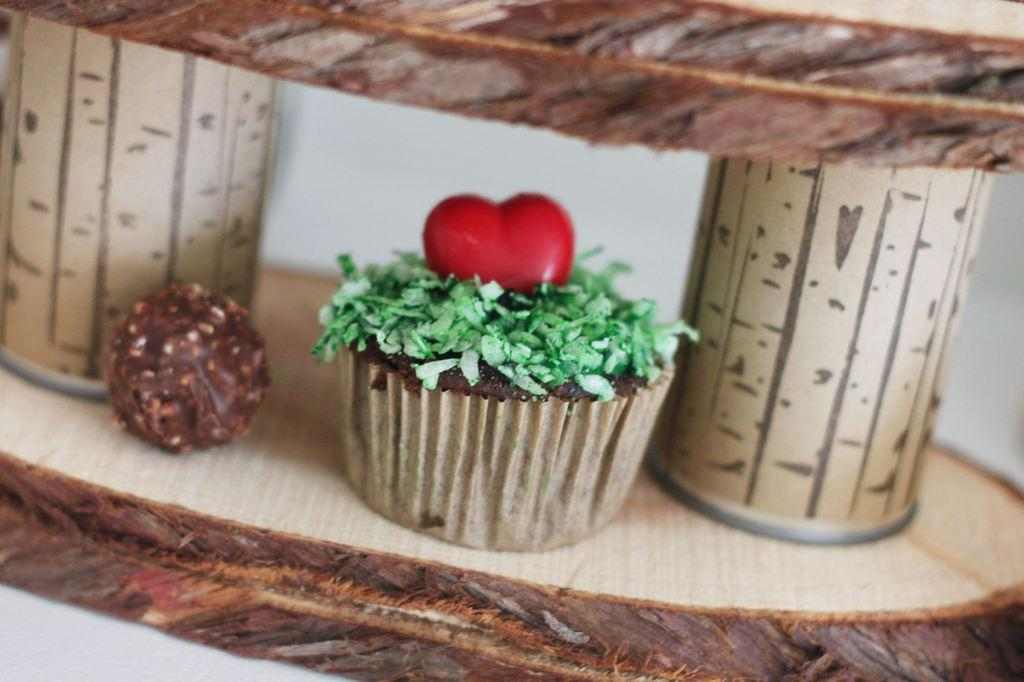What type of cake is shown in the image? There is a choco pie cake in the image. What ingredient is present in the cake and also visible in the image? There is chocolate in the image. What type of record can be seen playing in the background of the image? There is no record or music player visible in the image; it only features a choco pie cake and chocolate. 